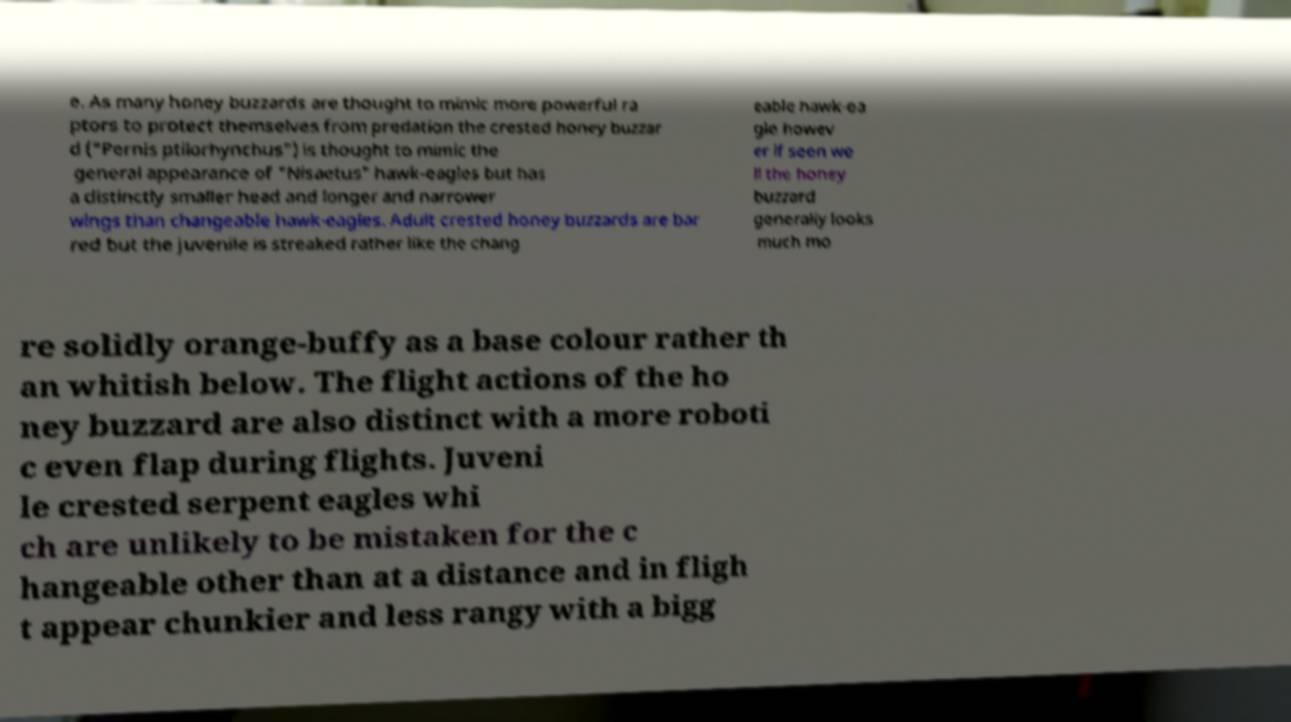I need the written content from this picture converted into text. Can you do that? e. As many honey buzzards are thought to mimic more powerful ra ptors to protect themselves from predation the crested honey buzzar d ("Pernis ptilorhynchus") is thought to mimic the general appearance of "Nisaetus" hawk-eagles but has a distinctly smaller head and longer and narrower wings than changeable hawk-eagles. Adult crested honey buzzards are bar red but the juvenile is streaked rather like the chang eable hawk-ea gle howev er if seen we ll the honey buzzard generally looks much mo re solidly orange-buffy as a base colour rather th an whitish below. The flight actions of the ho ney buzzard are also distinct with a more roboti c even flap during flights. Juveni le crested serpent eagles whi ch are unlikely to be mistaken for the c hangeable other than at a distance and in fligh t appear chunkier and less rangy with a bigg 